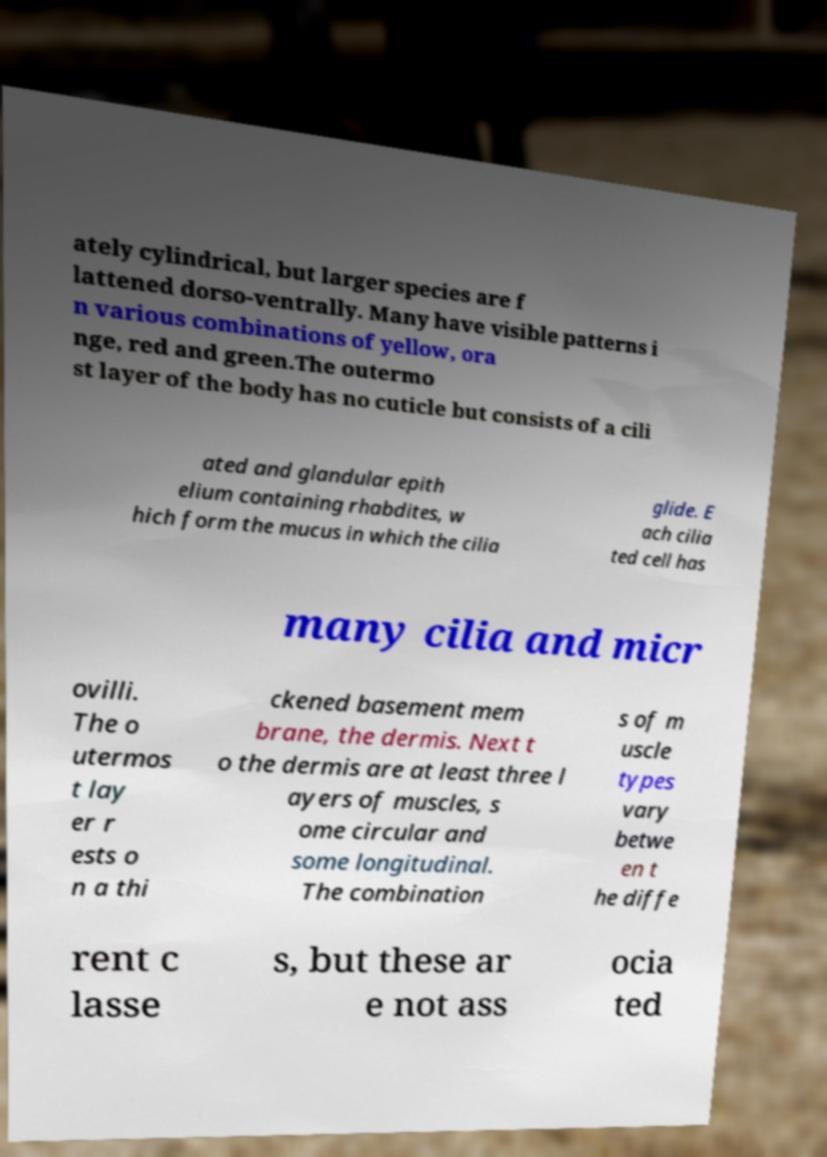Can you read and provide the text displayed in the image?This photo seems to have some interesting text. Can you extract and type it out for me? ately cylindrical, but larger species are f lattened dorso-ventrally. Many have visible patterns i n various combinations of yellow, ora nge, red and green.The outermo st layer of the body has no cuticle but consists of a cili ated and glandular epith elium containing rhabdites, w hich form the mucus in which the cilia glide. E ach cilia ted cell has many cilia and micr ovilli. The o utermos t lay er r ests o n a thi ckened basement mem brane, the dermis. Next t o the dermis are at least three l ayers of muscles, s ome circular and some longitudinal. The combination s of m uscle types vary betwe en t he diffe rent c lasse s, but these ar e not ass ocia ted 